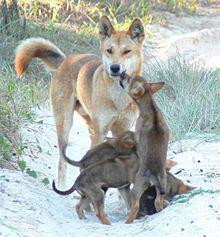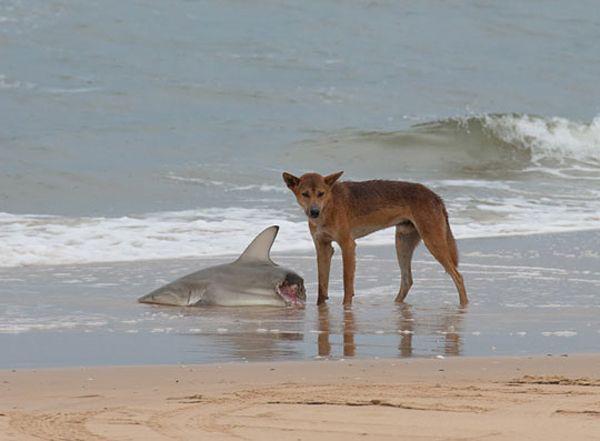The first image is the image on the left, the second image is the image on the right. Analyze the images presented: Is the assertion "A wild dog is standing near a half eaten shark in the image on the right." valid? Answer yes or no. Yes. 